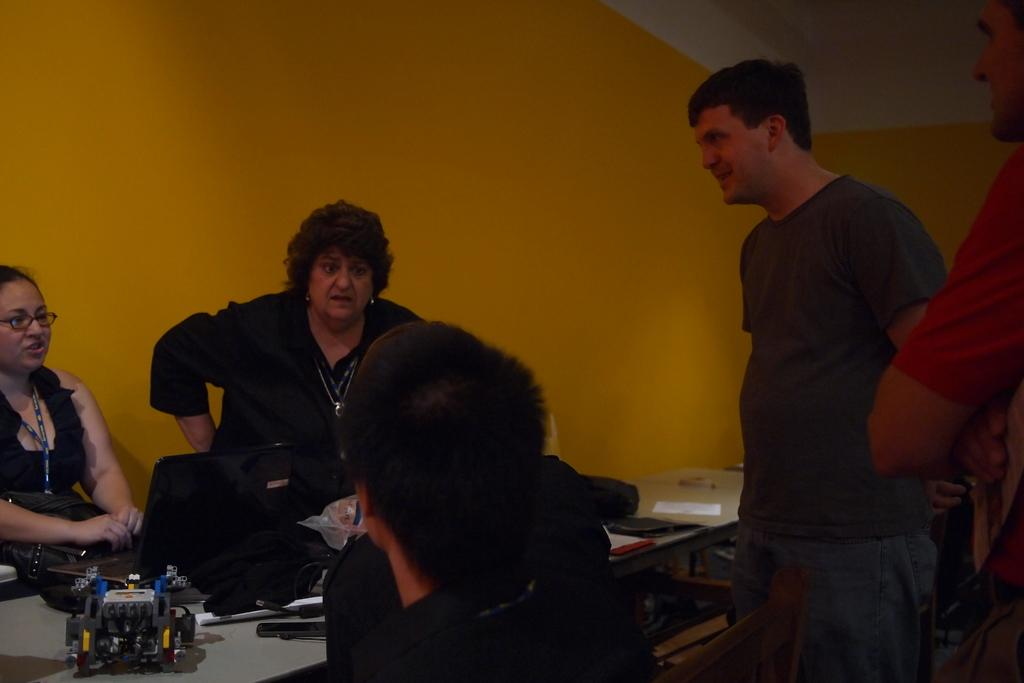How many people are present in the image? There are five people in the image. What are the people in the image doing? The people are having a conversation. Can you describe the facial expression of the man on the right side? The man on the right side is smiling. What type of vein is visible on the man's forehead in the image? There is no visible vein on the man's forehead in the image. What kind of tub is present in the image? There is no tub present in the image. 